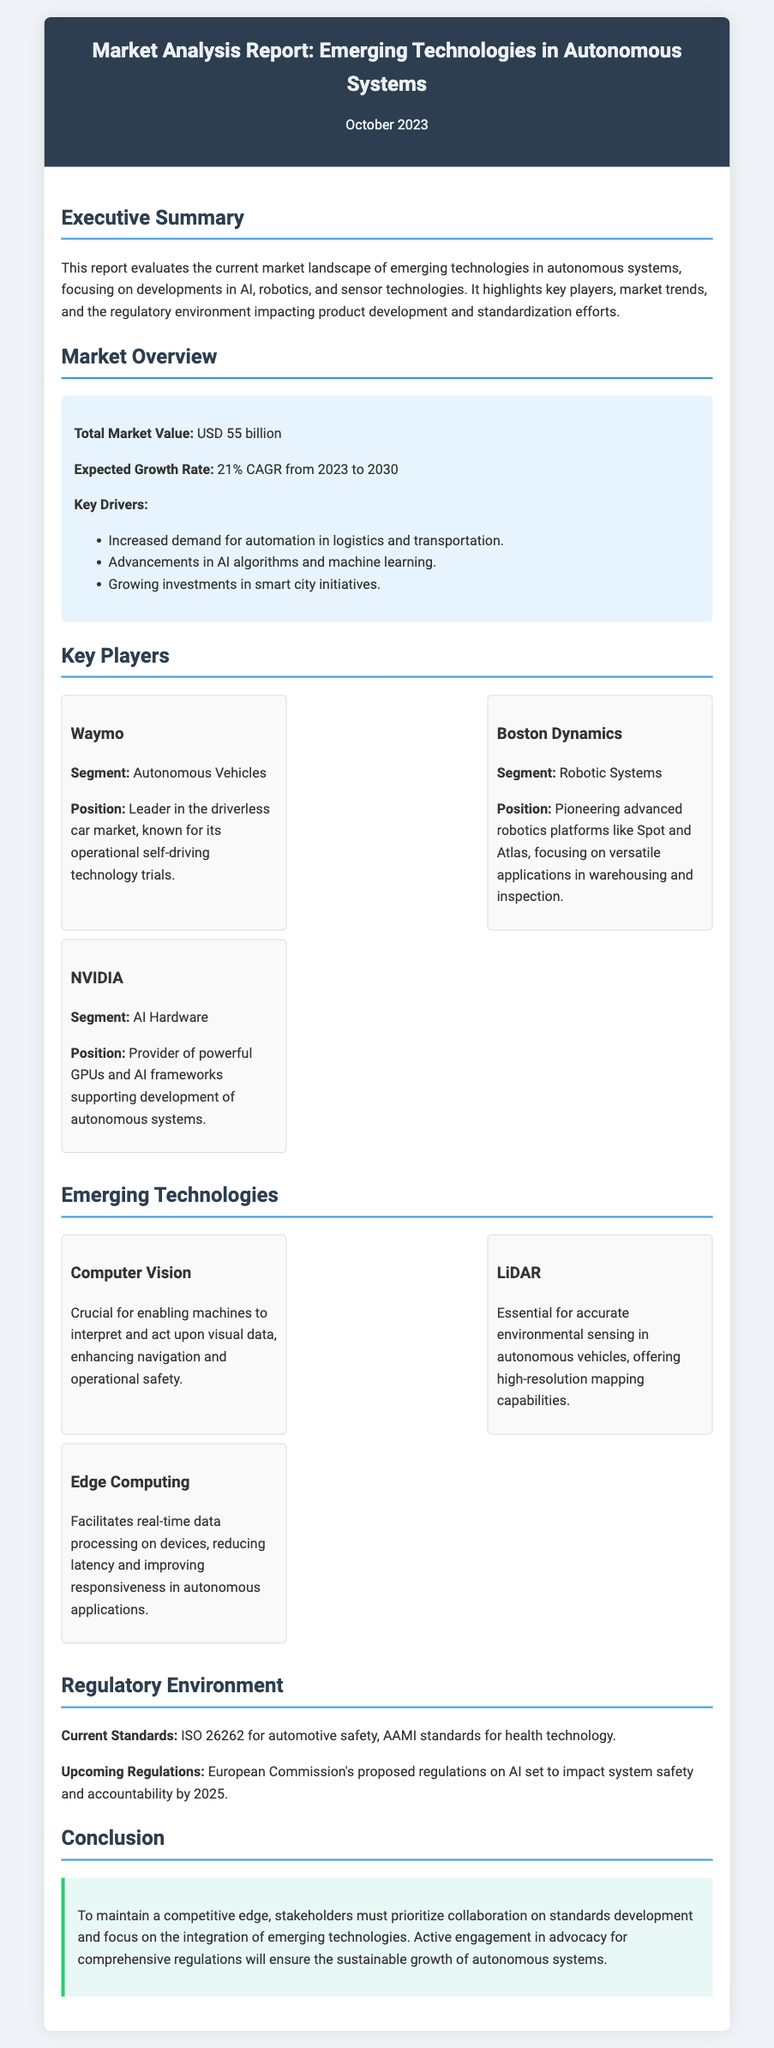what is the total market value? The total market value is specified in the document under the Market Overview section.
Answer: USD 55 billion what is the expected growth rate? The expected growth rate is mentioned in the same section, detailing the increase in market value over time.
Answer: 21% CAGR from 2023 to 2030 who is the leader in the driverless car market? This information is found in the Key Players section, identifying key market leaders.
Answer: Waymo which technology is essential for accurate environmental sensing? The Emerging Technologies section outlines key technologies, including their specific applications.
Answer: LiDAR what are the current standards mentioned? The Regulatory Environment section details existing regulations relevant to the field.
Answer: ISO 26262 for automotive safety what role does Edge Computing play? This is described in the context of emerging technologies and their capabilities in the document.
Answer: Real-time data processing what must stakeholders prioritize to maintain a competitive edge? The conclusion emphasizes the importance of cooperation for future advancements.
Answer: Collaboration on standards development what upcoming regulations are expected to impact system safety? This is outlined in the Regulatory Environment section regarding future industry impacts.
Answer: European Commission's proposed regulations on AI who pioneered advanced robotics platforms like Spot and Atlas? This is specified in the Key Players section, referencing a key player in Robotic Systems.
Answer: Boston Dynamics 